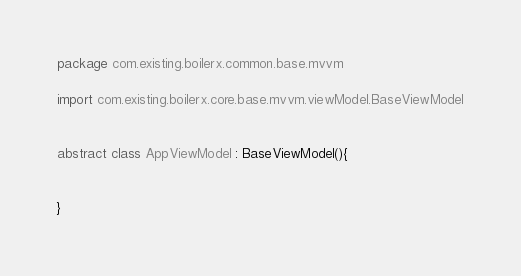<code> <loc_0><loc_0><loc_500><loc_500><_Kotlin_>package com.existing.boilerx.common.base.mvvm

import com.existing.boilerx.core.base.mvvm.viewModel.BaseViewModel


abstract class AppViewModel : BaseViewModel(){


}
</code> 